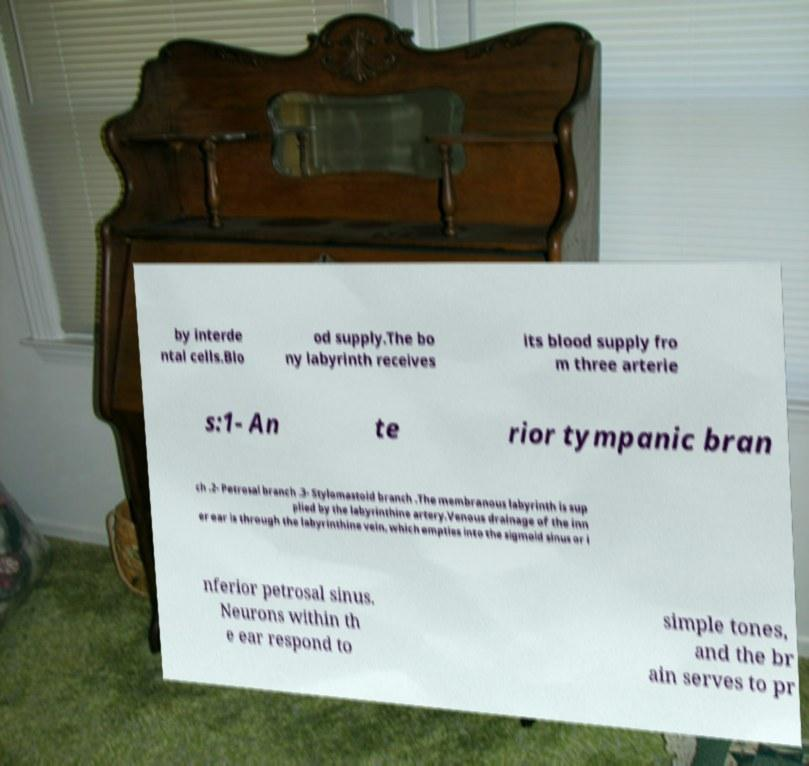Could you assist in decoding the text presented in this image and type it out clearly? by interde ntal cells.Blo od supply.The bo ny labyrinth receives its blood supply fro m three arterie s:1- An te rior tympanic bran ch .2- Petrosal branch .3- Stylomastoid branch .The membranous labyrinth is sup plied by the labyrinthine artery.Venous drainage of the inn er ear is through the labyrinthine vein, which empties into the sigmoid sinus or i nferior petrosal sinus. Neurons within th e ear respond to simple tones, and the br ain serves to pr 